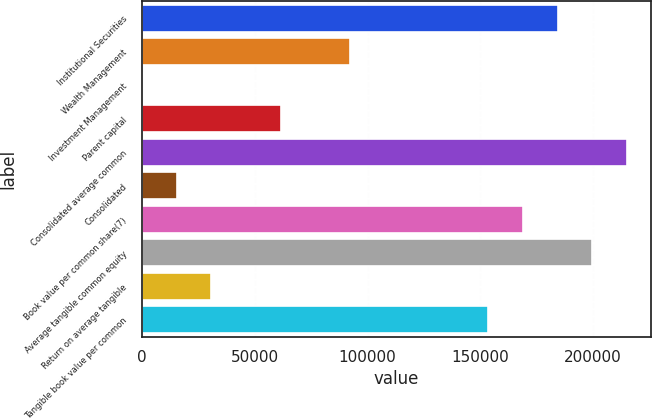Convert chart. <chart><loc_0><loc_0><loc_500><loc_500><bar_chart><fcel>Institutional Securities<fcel>Wealth Management<fcel>Investment Management<fcel>Parent capital<fcel>Consolidated average common<fcel>Consolidated<fcel>Book value per common share(7)<fcel>Average tangible common equity<fcel>Return on average tangible<fcel>Tangible book value per common<nl><fcel>184289<fcel>92146.1<fcel>2.8<fcel>61431.7<fcel>215004<fcel>15360<fcel>168932<fcel>199647<fcel>30717.2<fcel>153575<nl></chart> 